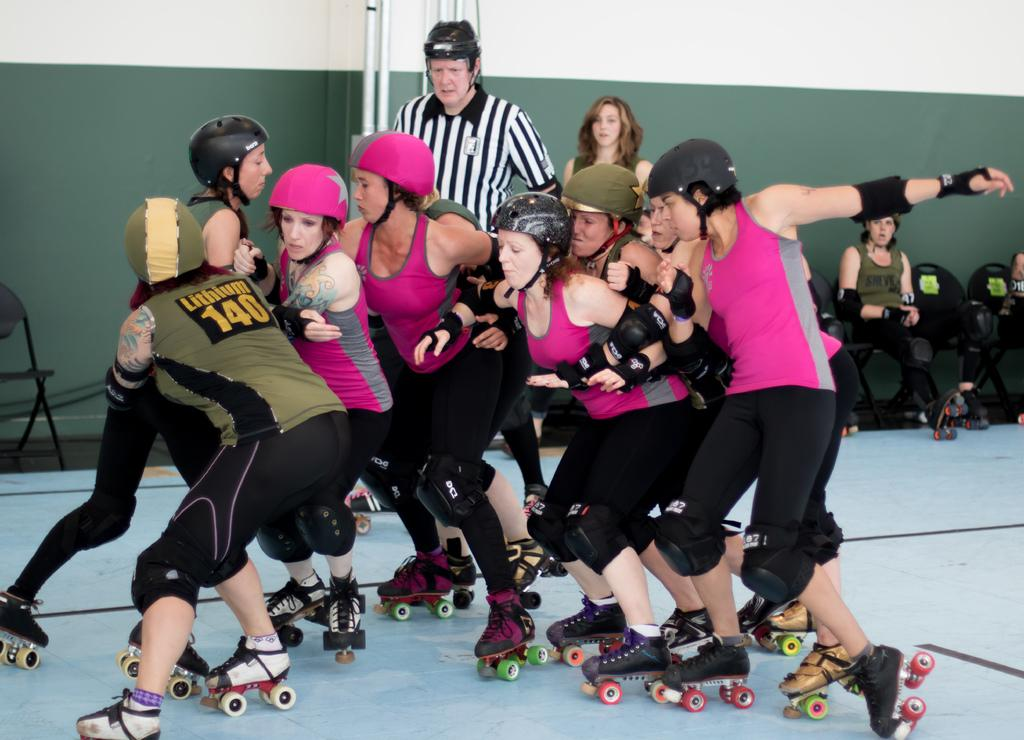<image>
Present a compact description of the photo's key features. A roller derby player with Lithium 140 on her shirt is battling the opposing team alongside her teammate. 